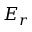Convert formula to latex. <formula><loc_0><loc_0><loc_500><loc_500>E _ { r }</formula> 